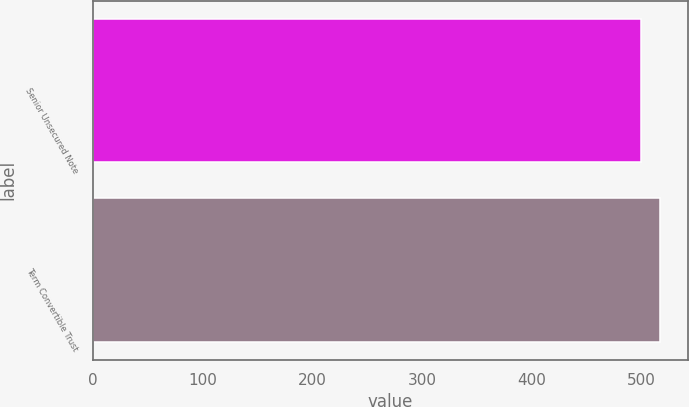Convert chart to OTSL. <chart><loc_0><loc_0><loc_500><loc_500><bar_chart><fcel>Senior Unsecured Note<fcel>Term Convertible Trust<nl><fcel>500<fcel>517<nl></chart> 